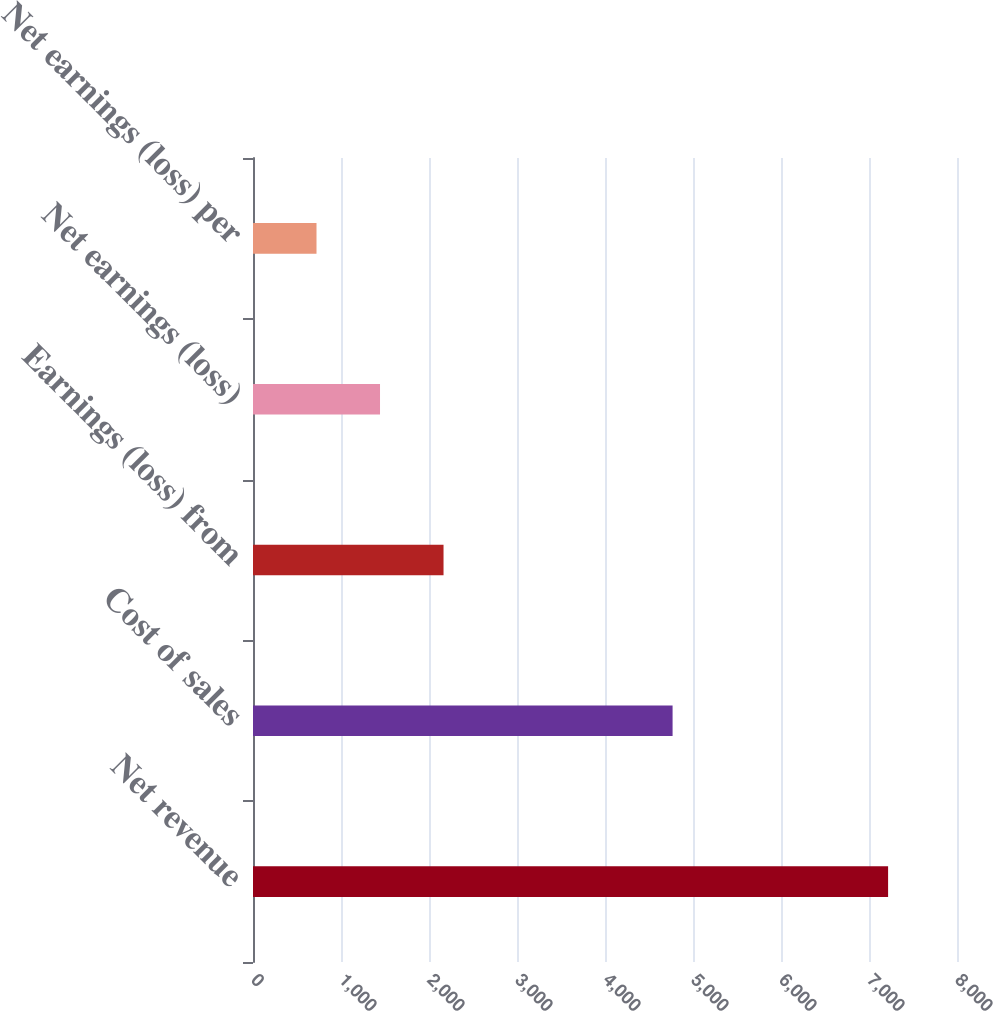Convert chart to OTSL. <chart><loc_0><loc_0><loc_500><loc_500><bar_chart><fcel>Net revenue<fcel>Cost of sales<fcel>Earnings (loss) from<fcel>Net earnings (loss)<fcel>Net earnings (loss) per<nl><fcel>7217<fcel>4768<fcel>2165.12<fcel>1443.42<fcel>721.72<nl></chart> 